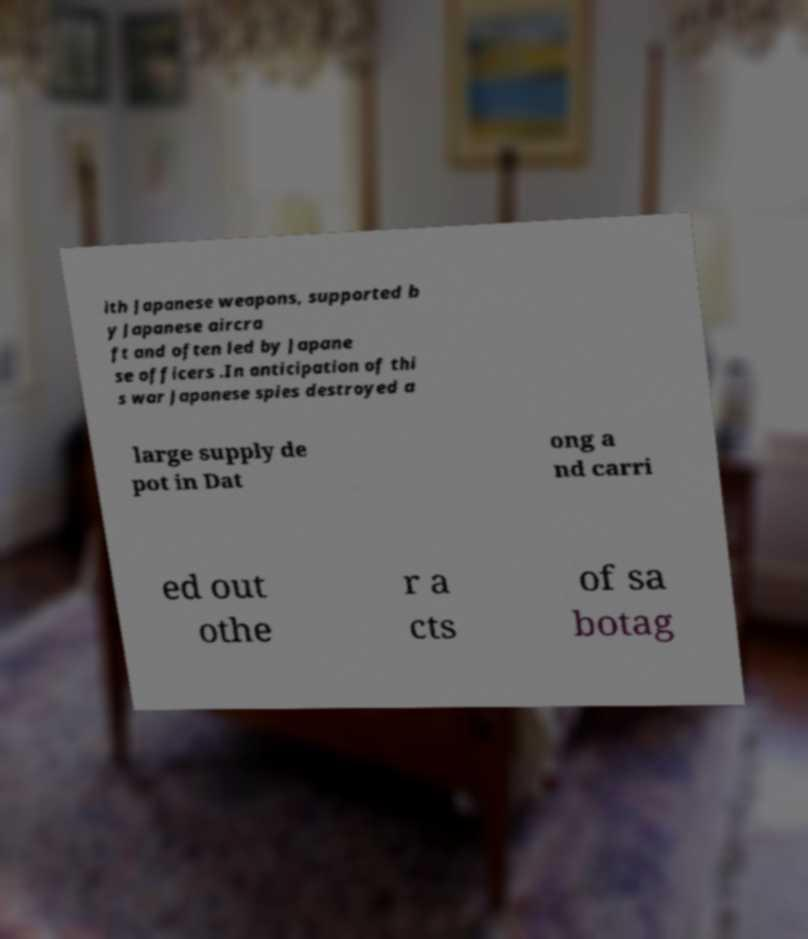What messages or text are displayed in this image? I need them in a readable, typed format. ith Japanese weapons, supported b y Japanese aircra ft and often led by Japane se officers .In anticipation of thi s war Japanese spies destroyed a large supply de pot in Dat ong a nd carri ed out othe r a cts of sa botag 